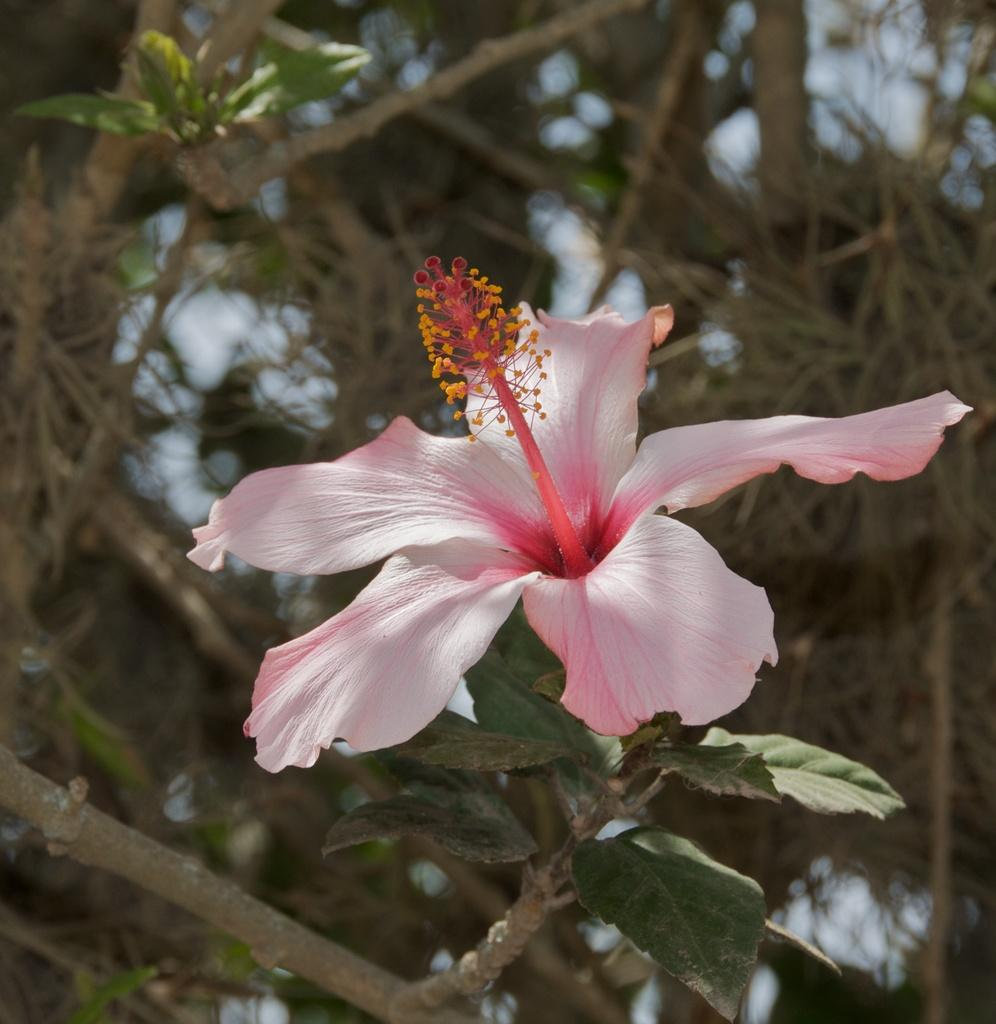What type of plant is in the center of the image? There is a pink color hibiscus plant in the center of the image. What can be seen in the background of the image? There are trees visible in the background of the image. How many loaves of bread are present in the image? There are no loaves of bread present in the image; it features a pink color hibiscus plant. How many eggs are visible in the image? There are no eggs visible in the image; it features a pink color hibiscus plant. 